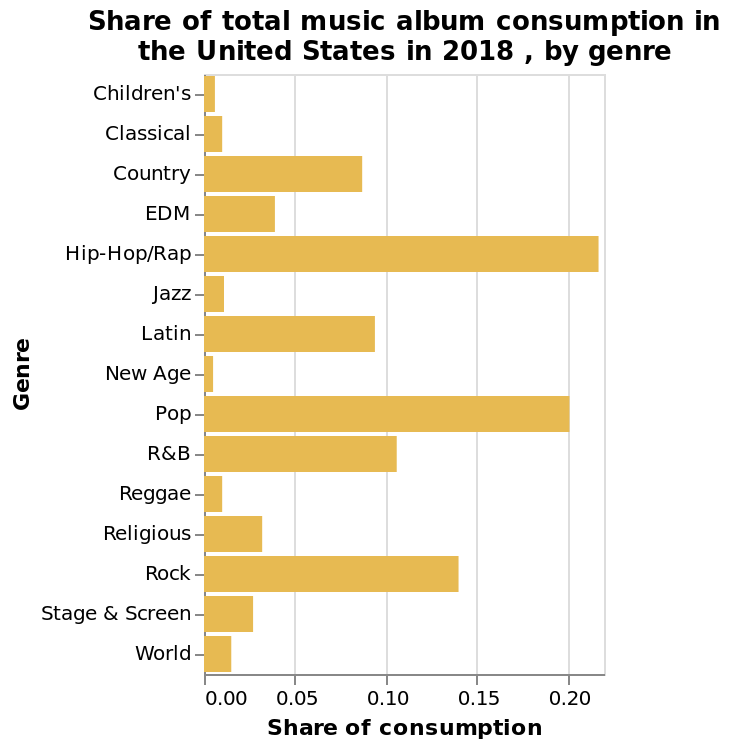<image>
please summary the statistics and relations of the chart Hip Hop/Rap & Pop hold a major share of the consumption market which reflects a more modern culture of music. Whereas music that has been around a lot longer in terms of origin is a lot less popular. What genres currently dominate the consumption market?  Hip Hop/Rap & Pop hold a major share of the consumption market. In which year was the data collected for this bar graph? The data for this bar graph was collected in the year 2018. 